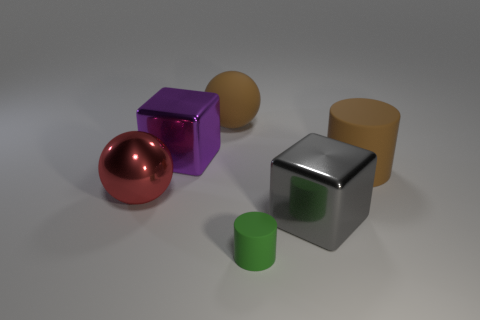Subtract all purple blocks. How many blocks are left? 1 Subtract all cubes. How many objects are left? 4 Subtract 1 cubes. How many cubes are left? 1 Add 2 tiny green objects. How many objects exist? 8 Subtract all brown balls. Subtract all purple blocks. How many balls are left? 1 Subtract all yellow cubes. How many brown spheres are left? 1 Subtract all purple objects. Subtract all purple cubes. How many objects are left? 4 Add 5 large red shiny objects. How many large red shiny objects are left? 6 Add 6 purple metallic cubes. How many purple metallic cubes exist? 7 Subtract 0 blue balls. How many objects are left? 6 